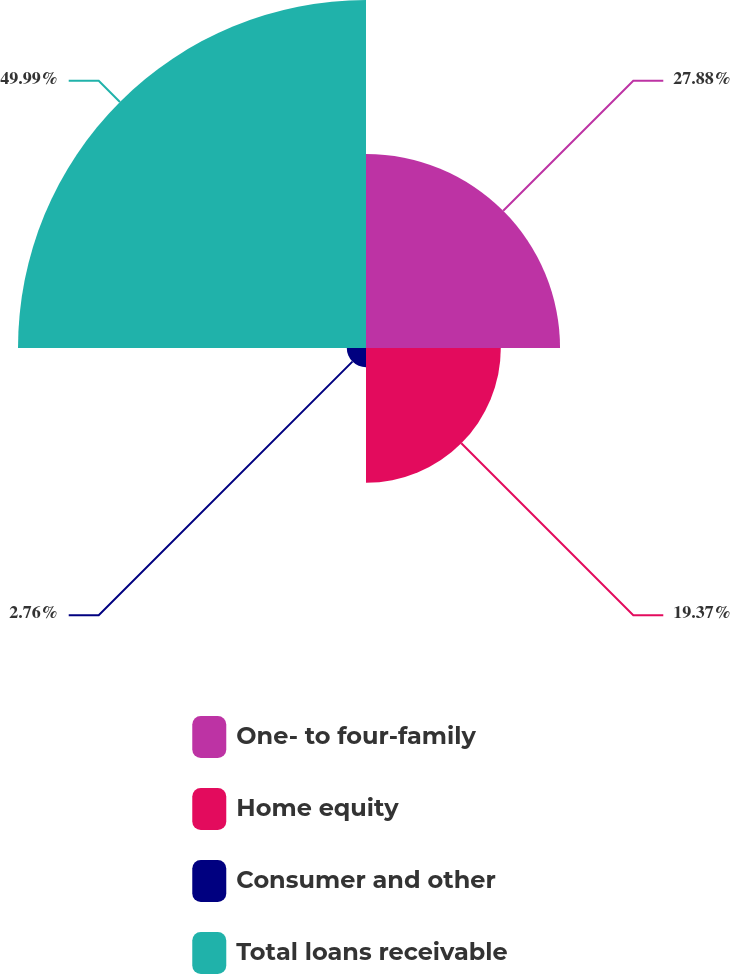Convert chart. <chart><loc_0><loc_0><loc_500><loc_500><pie_chart><fcel>One- to four-family<fcel>Home equity<fcel>Consumer and other<fcel>Total loans receivable<nl><fcel>27.88%<fcel>19.37%<fcel>2.76%<fcel>50.0%<nl></chart> 